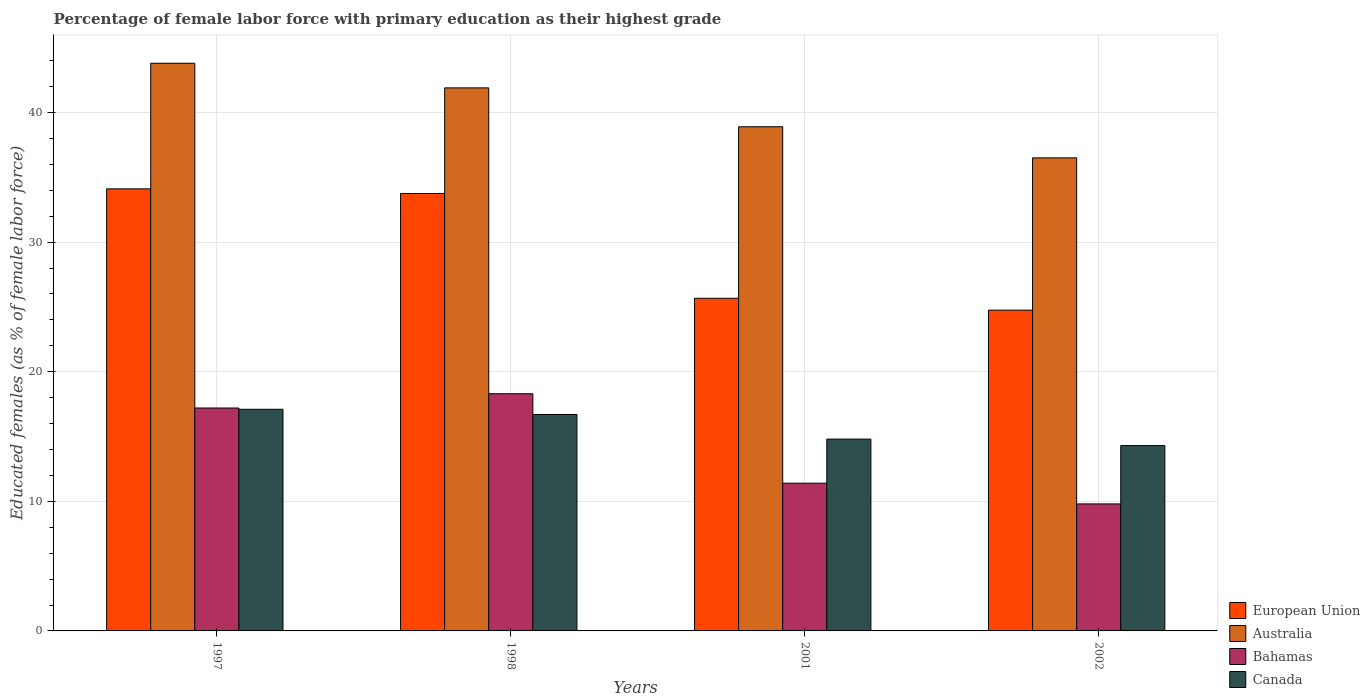How many different coloured bars are there?
Your answer should be very brief. 4. How many groups of bars are there?
Provide a short and direct response. 4. How many bars are there on the 1st tick from the right?
Provide a succinct answer. 4. In how many cases, is the number of bars for a given year not equal to the number of legend labels?
Give a very brief answer. 0. What is the percentage of female labor force with primary education in Australia in 2001?
Your answer should be compact. 38.9. Across all years, what is the maximum percentage of female labor force with primary education in Bahamas?
Give a very brief answer. 18.3. Across all years, what is the minimum percentage of female labor force with primary education in European Union?
Ensure brevity in your answer.  24.75. In which year was the percentage of female labor force with primary education in Bahamas maximum?
Provide a succinct answer. 1998. What is the total percentage of female labor force with primary education in Australia in the graph?
Your answer should be very brief. 161.1. What is the difference between the percentage of female labor force with primary education in Canada in 1997 and that in 1998?
Your response must be concise. 0.4. What is the difference between the percentage of female labor force with primary education in Canada in 1998 and the percentage of female labor force with primary education in Australia in 2001?
Offer a very short reply. -22.2. What is the average percentage of female labor force with primary education in Australia per year?
Make the answer very short. 40.28. In the year 1997, what is the difference between the percentage of female labor force with primary education in European Union and percentage of female labor force with primary education in Canada?
Your answer should be very brief. 17.01. In how many years, is the percentage of female labor force with primary education in Canada greater than 36 %?
Offer a very short reply. 0. What is the ratio of the percentage of female labor force with primary education in European Union in 1997 to that in 2002?
Provide a succinct answer. 1.38. What is the difference between the highest and the second highest percentage of female labor force with primary education in Bahamas?
Offer a terse response. 1.1. What is the difference between the highest and the lowest percentage of female labor force with primary education in Australia?
Provide a short and direct response. 7.3. In how many years, is the percentage of female labor force with primary education in Australia greater than the average percentage of female labor force with primary education in Australia taken over all years?
Make the answer very short. 2. Is it the case that in every year, the sum of the percentage of female labor force with primary education in Canada and percentage of female labor force with primary education in Australia is greater than the sum of percentage of female labor force with primary education in Bahamas and percentage of female labor force with primary education in European Union?
Make the answer very short. Yes. What does the 2nd bar from the left in 1997 represents?
Provide a short and direct response. Australia. What does the 2nd bar from the right in 2001 represents?
Make the answer very short. Bahamas. Is it the case that in every year, the sum of the percentage of female labor force with primary education in Australia and percentage of female labor force with primary education in Bahamas is greater than the percentage of female labor force with primary education in European Union?
Provide a succinct answer. Yes. Are all the bars in the graph horizontal?
Provide a short and direct response. No. What is the difference between two consecutive major ticks on the Y-axis?
Provide a short and direct response. 10. Does the graph contain grids?
Your response must be concise. Yes. What is the title of the graph?
Give a very brief answer. Percentage of female labor force with primary education as their highest grade. Does "Comoros" appear as one of the legend labels in the graph?
Ensure brevity in your answer.  No. What is the label or title of the X-axis?
Your response must be concise. Years. What is the label or title of the Y-axis?
Provide a succinct answer. Educated females (as % of female labor force). What is the Educated females (as % of female labor force) of European Union in 1997?
Ensure brevity in your answer.  34.11. What is the Educated females (as % of female labor force) of Australia in 1997?
Provide a succinct answer. 43.8. What is the Educated females (as % of female labor force) of Bahamas in 1997?
Keep it short and to the point. 17.2. What is the Educated females (as % of female labor force) in Canada in 1997?
Offer a very short reply. 17.1. What is the Educated females (as % of female labor force) of European Union in 1998?
Make the answer very short. 33.75. What is the Educated females (as % of female labor force) in Australia in 1998?
Ensure brevity in your answer.  41.9. What is the Educated females (as % of female labor force) of Bahamas in 1998?
Your answer should be very brief. 18.3. What is the Educated females (as % of female labor force) in Canada in 1998?
Your answer should be compact. 16.7. What is the Educated females (as % of female labor force) in European Union in 2001?
Offer a very short reply. 25.67. What is the Educated females (as % of female labor force) in Australia in 2001?
Keep it short and to the point. 38.9. What is the Educated females (as % of female labor force) of Bahamas in 2001?
Ensure brevity in your answer.  11.4. What is the Educated females (as % of female labor force) of Canada in 2001?
Provide a succinct answer. 14.8. What is the Educated females (as % of female labor force) in European Union in 2002?
Ensure brevity in your answer.  24.75. What is the Educated females (as % of female labor force) of Australia in 2002?
Offer a very short reply. 36.5. What is the Educated females (as % of female labor force) in Bahamas in 2002?
Provide a succinct answer. 9.8. What is the Educated females (as % of female labor force) in Canada in 2002?
Make the answer very short. 14.3. Across all years, what is the maximum Educated females (as % of female labor force) in European Union?
Provide a short and direct response. 34.11. Across all years, what is the maximum Educated females (as % of female labor force) in Australia?
Ensure brevity in your answer.  43.8. Across all years, what is the maximum Educated females (as % of female labor force) in Bahamas?
Your answer should be compact. 18.3. Across all years, what is the maximum Educated females (as % of female labor force) of Canada?
Keep it short and to the point. 17.1. Across all years, what is the minimum Educated females (as % of female labor force) of European Union?
Your answer should be very brief. 24.75. Across all years, what is the minimum Educated females (as % of female labor force) of Australia?
Make the answer very short. 36.5. Across all years, what is the minimum Educated females (as % of female labor force) of Bahamas?
Provide a succinct answer. 9.8. Across all years, what is the minimum Educated females (as % of female labor force) in Canada?
Your answer should be very brief. 14.3. What is the total Educated females (as % of female labor force) of European Union in the graph?
Offer a terse response. 118.28. What is the total Educated females (as % of female labor force) in Australia in the graph?
Make the answer very short. 161.1. What is the total Educated females (as % of female labor force) in Bahamas in the graph?
Give a very brief answer. 56.7. What is the total Educated females (as % of female labor force) of Canada in the graph?
Offer a terse response. 62.9. What is the difference between the Educated females (as % of female labor force) in European Union in 1997 and that in 1998?
Your answer should be very brief. 0.36. What is the difference between the Educated females (as % of female labor force) of Canada in 1997 and that in 1998?
Your response must be concise. 0.4. What is the difference between the Educated females (as % of female labor force) of European Union in 1997 and that in 2001?
Offer a very short reply. 8.44. What is the difference between the Educated females (as % of female labor force) of Australia in 1997 and that in 2001?
Make the answer very short. 4.9. What is the difference between the Educated females (as % of female labor force) of Canada in 1997 and that in 2001?
Keep it short and to the point. 2.3. What is the difference between the Educated females (as % of female labor force) in European Union in 1997 and that in 2002?
Your response must be concise. 9.36. What is the difference between the Educated females (as % of female labor force) of Bahamas in 1997 and that in 2002?
Ensure brevity in your answer.  7.4. What is the difference between the Educated females (as % of female labor force) in European Union in 1998 and that in 2001?
Provide a succinct answer. 8.08. What is the difference between the Educated females (as % of female labor force) of Australia in 1998 and that in 2001?
Your answer should be compact. 3. What is the difference between the Educated females (as % of female labor force) in Bahamas in 1998 and that in 2001?
Your answer should be compact. 6.9. What is the difference between the Educated females (as % of female labor force) in Canada in 1998 and that in 2001?
Offer a very short reply. 1.9. What is the difference between the Educated females (as % of female labor force) in European Union in 1998 and that in 2002?
Ensure brevity in your answer.  9. What is the difference between the Educated females (as % of female labor force) of Australia in 1998 and that in 2002?
Your answer should be very brief. 5.4. What is the difference between the Educated females (as % of female labor force) in Bahamas in 1998 and that in 2002?
Ensure brevity in your answer.  8.5. What is the difference between the Educated females (as % of female labor force) of Canada in 1998 and that in 2002?
Your answer should be very brief. 2.4. What is the difference between the Educated females (as % of female labor force) of European Union in 2001 and that in 2002?
Your answer should be compact. 0.92. What is the difference between the Educated females (as % of female labor force) of Australia in 2001 and that in 2002?
Give a very brief answer. 2.4. What is the difference between the Educated females (as % of female labor force) of Bahamas in 2001 and that in 2002?
Your response must be concise. 1.6. What is the difference between the Educated females (as % of female labor force) in European Union in 1997 and the Educated females (as % of female labor force) in Australia in 1998?
Make the answer very short. -7.79. What is the difference between the Educated females (as % of female labor force) of European Union in 1997 and the Educated females (as % of female labor force) of Bahamas in 1998?
Make the answer very short. 15.81. What is the difference between the Educated females (as % of female labor force) of European Union in 1997 and the Educated females (as % of female labor force) of Canada in 1998?
Give a very brief answer. 17.41. What is the difference between the Educated females (as % of female labor force) of Australia in 1997 and the Educated females (as % of female labor force) of Canada in 1998?
Provide a short and direct response. 27.1. What is the difference between the Educated females (as % of female labor force) of European Union in 1997 and the Educated females (as % of female labor force) of Australia in 2001?
Offer a very short reply. -4.79. What is the difference between the Educated females (as % of female labor force) of European Union in 1997 and the Educated females (as % of female labor force) of Bahamas in 2001?
Provide a short and direct response. 22.71. What is the difference between the Educated females (as % of female labor force) in European Union in 1997 and the Educated females (as % of female labor force) in Canada in 2001?
Provide a succinct answer. 19.31. What is the difference between the Educated females (as % of female labor force) in Australia in 1997 and the Educated females (as % of female labor force) in Bahamas in 2001?
Provide a short and direct response. 32.4. What is the difference between the Educated females (as % of female labor force) in Bahamas in 1997 and the Educated females (as % of female labor force) in Canada in 2001?
Ensure brevity in your answer.  2.4. What is the difference between the Educated females (as % of female labor force) in European Union in 1997 and the Educated females (as % of female labor force) in Australia in 2002?
Your response must be concise. -2.39. What is the difference between the Educated females (as % of female labor force) in European Union in 1997 and the Educated females (as % of female labor force) in Bahamas in 2002?
Make the answer very short. 24.31. What is the difference between the Educated females (as % of female labor force) of European Union in 1997 and the Educated females (as % of female labor force) of Canada in 2002?
Provide a short and direct response. 19.81. What is the difference between the Educated females (as % of female labor force) of Australia in 1997 and the Educated females (as % of female labor force) of Bahamas in 2002?
Give a very brief answer. 34. What is the difference between the Educated females (as % of female labor force) in Australia in 1997 and the Educated females (as % of female labor force) in Canada in 2002?
Provide a short and direct response. 29.5. What is the difference between the Educated females (as % of female labor force) of Bahamas in 1997 and the Educated females (as % of female labor force) of Canada in 2002?
Your response must be concise. 2.9. What is the difference between the Educated females (as % of female labor force) in European Union in 1998 and the Educated females (as % of female labor force) in Australia in 2001?
Your response must be concise. -5.15. What is the difference between the Educated females (as % of female labor force) in European Union in 1998 and the Educated females (as % of female labor force) in Bahamas in 2001?
Provide a succinct answer. 22.35. What is the difference between the Educated females (as % of female labor force) of European Union in 1998 and the Educated females (as % of female labor force) of Canada in 2001?
Provide a succinct answer. 18.95. What is the difference between the Educated females (as % of female labor force) of Australia in 1998 and the Educated females (as % of female labor force) of Bahamas in 2001?
Give a very brief answer. 30.5. What is the difference between the Educated females (as % of female labor force) of Australia in 1998 and the Educated females (as % of female labor force) of Canada in 2001?
Ensure brevity in your answer.  27.1. What is the difference between the Educated females (as % of female labor force) of European Union in 1998 and the Educated females (as % of female labor force) of Australia in 2002?
Give a very brief answer. -2.75. What is the difference between the Educated females (as % of female labor force) in European Union in 1998 and the Educated females (as % of female labor force) in Bahamas in 2002?
Give a very brief answer. 23.95. What is the difference between the Educated females (as % of female labor force) of European Union in 1998 and the Educated females (as % of female labor force) of Canada in 2002?
Ensure brevity in your answer.  19.45. What is the difference between the Educated females (as % of female labor force) of Australia in 1998 and the Educated females (as % of female labor force) of Bahamas in 2002?
Make the answer very short. 32.1. What is the difference between the Educated females (as % of female labor force) of Australia in 1998 and the Educated females (as % of female labor force) of Canada in 2002?
Give a very brief answer. 27.6. What is the difference between the Educated females (as % of female labor force) in Bahamas in 1998 and the Educated females (as % of female labor force) in Canada in 2002?
Ensure brevity in your answer.  4. What is the difference between the Educated females (as % of female labor force) in European Union in 2001 and the Educated females (as % of female labor force) in Australia in 2002?
Offer a terse response. -10.83. What is the difference between the Educated females (as % of female labor force) of European Union in 2001 and the Educated females (as % of female labor force) of Bahamas in 2002?
Your response must be concise. 15.87. What is the difference between the Educated females (as % of female labor force) of European Union in 2001 and the Educated females (as % of female labor force) of Canada in 2002?
Your answer should be compact. 11.37. What is the difference between the Educated females (as % of female labor force) of Australia in 2001 and the Educated females (as % of female labor force) of Bahamas in 2002?
Ensure brevity in your answer.  29.1. What is the difference between the Educated females (as % of female labor force) of Australia in 2001 and the Educated females (as % of female labor force) of Canada in 2002?
Offer a very short reply. 24.6. What is the difference between the Educated females (as % of female labor force) in Bahamas in 2001 and the Educated females (as % of female labor force) in Canada in 2002?
Provide a succinct answer. -2.9. What is the average Educated females (as % of female labor force) in European Union per year?
Keep it short and to the point. 29.57. What is the average Educated females (as % of female labor force) in Australia per year?
Keep it short and to the point. 40.27. What is the average Educated females (as % of female labor force) of Bahamas per year?
Offer a very short reply. 14.18. What is the average Educated females (as % of female labor force) in Canada per year?
Ensure brevity in your answer.  15.72. In the year 1997, what is the difference between the Educated females (as % of female labor force) of European Union and Educated females (as % of female labor force) of Australia?
Keep it short and to the point. -9.69. In the year 1997, what is the difference between the Educated females (as % of female labor force) in European Union and Educated females (as % of female labor force) in Bahamas?
Make the answer very short. 16.91. In the year 1997, what is the difference between the Educated females (as % of female labor force) of European Union and Educated females (as % of female labor force) of Canada?
Your answer should be very brief. 17.01. In the year 1997, what is the difference between the Educated females (as % of female labor force) in Australia and Educated females (as % of female labor force) in Bahamas?
Your response must be concise. 26.6. In the year 1997, what is the difference between the Educated females (as % of female labor force) in Australia and Educated females (as % of female labor force) in Canada?
Provide a short and direct response. 26.7. In the year 1998, what is the difference between the Educated females (as % of female labor force) of European Union and Educated females (as % of female labor force) of Australia?
Keep it short and to the point. -8.15. In the year 1998, what is the difference between the Educated females (as % of female labor force) of European Union and Educated females (as % of female labor force) of Bahamas?
Offer a very short reply. 15.45. In the year 1998, what is the difference between the Educated females (as % of female labor force) of European Union and Educated females (as % of female labor force) of Canada?
Your answer should be compact. 17.05. In the year 1998, what is the difference between the Educated females (as % of female labor force) of Australia and Educated females (as % of female labor force) of Bahamas?
Offer a very short reply. 23.6. In the year 1998, what is the difference between the Educated females (as % of female labor force) in Australia and Educated females (as % of female labor force) in Canada?
Make the answer very short. 25.2. In the year 2001, what is the difference between the Educated females (as % of female labor force) in European Union and Educated females (as % of female labor force) in Australia?
Your answer should be compact. -13.23. In the year 2001, what is the difference between the Educated females (as % of female labor force) of European Union and Educated females (as % of female labor force) of Bahamas?
Offer a terse response. 14.27. In the year 2001, what is the difference between the Educated females (as % of female labor force) of European Union and Educated females (as % of female labor force) of Canada?
Offer a terse response. 10.87. In the year 2001, what is the difference between the Educated females (as % of female labor force) in Australia and Educated females (as % of female labor force) in Bahamas?
Keep it short and to the point. 27.5. In the year 2001, what is the difference between the Educated females (as % of female labor force) of Australia and Educated females (as % of female labor force) of Canada?
Offer a terse response. 24.1. In the year 2001, what is the difference between the Educated females (as % of female labor force) in Bahamas and Educated females (as % of female labor force) in Canada?
Provide a succinct answer. -3.4. In the year 2002, what is the difference between the Educated females (as % of female labor force) in European Union and Educated females (as % of female labor force) in Australia?
Provide a succinct answer. -11.75. In the year 2002, what is the difference between the Educated females (as % of female labor force) in European Union and Educated females (as % of female labor force) in Bahamas?
Keep it short and to the point. 14.95. In the year 2002, what is the difference between the Educated females (as % of female labor force) in European Union and Educated females (as % of female labor force) in Canada?
Your response must be concise. 10.45. In the year 2002, what is the difference between the Educated females (as % of female labor force) of Australia and Educated females (as % of female labor force) of Bahamas?
Give a very brief answer. 26.7. What is the ratio of the Educated females (as % of female labor force) in European Union in 1997 to that in 1998?
Your answer should be very brief. 1.01. What is the ratio of the Educated females (as % of female labor force) in Australia in 1997 to that in 1998?
Provide a succinct answer. 1.05. What is the ratio of the Educated females (as % of female labor force) of Bahamas in 1997 to that in 1998?
Give a very brief answer. 0.94. What is the ratio of the Educated females (as % of female labor force) in Canada in 1997 to that in 1998?
Your response must be concise. 1.02. What is the ratio of the Educated females (as % of female labor force) of European Union in 1997 to that in 2001?
Ensure brevity in your answer.  1.33. What is the ratio of the Educated females (as % of female labor force) in Australia in 1997 to that in 2001?
Offer a very short reply. 1.13. What is the ratio of the Educated females (as % of female labor force) of Bahamas in 1997 to that in 2001?
Offer a terse response. 1.51. What is the ratio of the Educated females (as % of female labor force) of Canada in 1997 to that in 2001?
Offer a terse response. 1.16. What is the ratio of the Educated females (as % of female labor force) of European Union in 1997 to that in 2002?
Keep it short and to the point. 1.38. What is the ratio of the Educated females (as % of female labor force) in Australia in 1997 to that in 2002?
Provide a succinct answer. 1.2. What is the ratio of the Educated females (as % of female labor force) of Bahamas in 1997 to that in 2002?
Your answer should be compact. 1.76. What is the ratio of the Educated females (as % of female labor force) in Canada in 1997 to that in 2002?
Give a very brief answer. 1.2. What is the ratio of the Educated females (as % of female labor force) in European Union in 1998 to that in 2001?
Keep it short and to the point. 1.31. What is the ratio of the Educated females (as % of female labor force) in Australia in 1998 to that in 2001?
Offer a terse response. 1.08. What is the ratio of the Educated females (as % of female labor force) in Bahamas in 1998 to that in 2001?
Give a very brief answer. 1.61. What is the ratio of the Educated females (as % of female labor force) of Canada in 1998 to that in 2001?
Provide a short and direct response. 1.13. What is the ratio of the Educated females (as % of female labor force) of European Union in 1998 to that in 2002?
Your response must be concise. 1.36. What is the ratio of the Educated females (as % of female labor force) of Australia in 1998 to that in 2002?
Ensure brevity in your answer.  1.15. What is the ratio of the Educated females (as % of female labor force) in Bahamas in 1998 to that in 2002?
Provide a short and direct response. 1.87. What is the ratio of the Educated females (as % of female labor force) of Canada in 1998 to that in 2002?
Give a very brief answer. 1.17. What is the ratio of the Educated females (as % of female labor force) of European Union in 2001 to that in 2002?
Your answer should be very brief. 1.04. What is the ratio of the Educated females (as % of female labor force) of Australia in 2001 to that in 2002?
Offer a very short reply. 1.07. What is the ratio of the Educated females (as % of female labor force) in Bahamas in 2001 to that in 2002?
Keep it short and to the point. 1.16. What is the ratio of the Educated females (as % of female labor force) in Canada in 2001 to that in 2002?
Offer a terse response. 1.03. What is the difference between the highest and the second highest Educated females (as % of female labor force) of European Union?
Your response must be concise. 0.36. What is the difference between the highest and the second highest Educated females (as % of female labor force) of Australia?
Your answer should be compact. 1.9. What is the difference between the highest and the second highest Educated females (as % of female labor force) in Bahamas?
Provide a short and direct response. 1.1. What is the difference between the highest and the lowest Educated females (as % of female labor force) of European Union?
Give a very brief answer. 9.36. What is the difference between the highest and the lowest Educated females (as % of female labor force) of Australia?
Ensure brevity in your answer.  7.3. What is the difference between the highest and the lowest Educated females (as % of female labor force) in Bahamas?
Provide a short and direct response. 8.5. What is the difference between the highest and the lowest Educated females (as % of female labor force) of Canada?
Give a very brief answer. 2.8. 